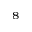<formula> <loc_0><loc_0><loc_500><loc_500>^ { 8 }</formula> 